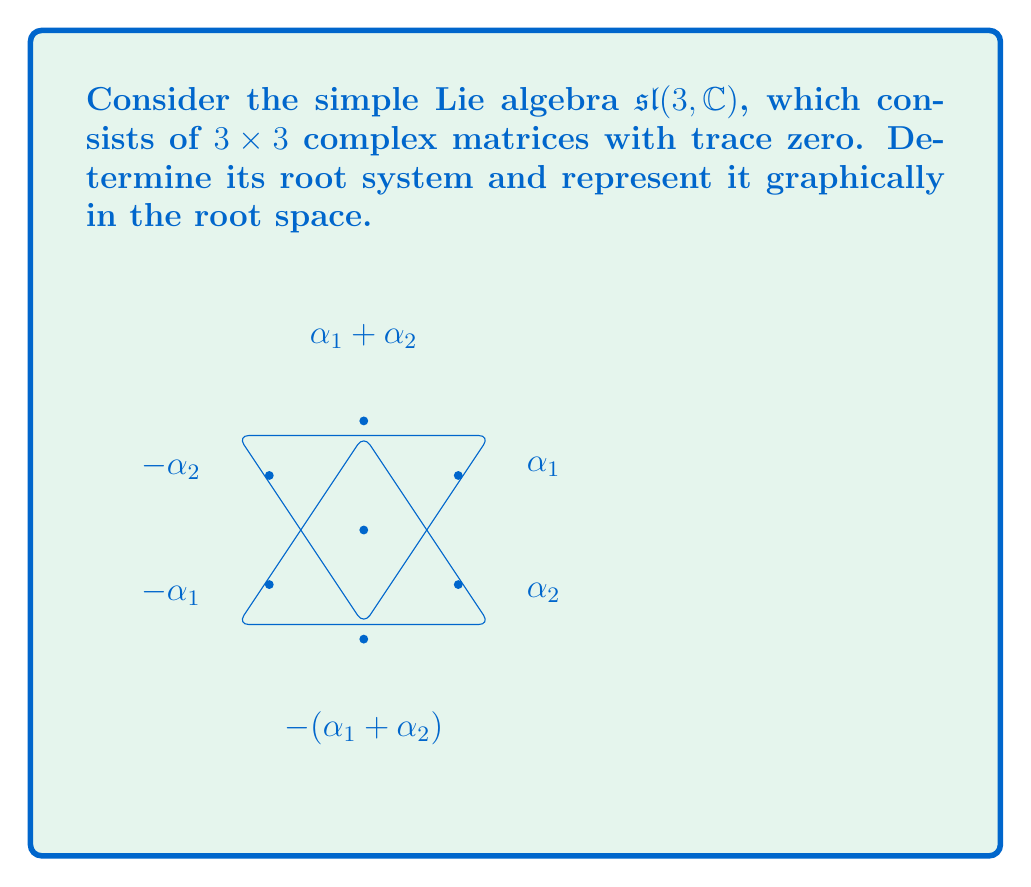Help me with this question. To find the root system of $\mathfrak{sl}(3, \mathbb{C})$, we follow these steps:

1) First, identify a Cartan subalgebra $\mathfrak{h}$. For $\mathfrak{sl}(3, \mathbb{C})$, we can choose the diagonal matrices with trace zero:

   $$\mathfrak{h} = \left\{\begin{pmatrix} a & 0 & 0 \\ 0 & b & 0 \\ 0 & 0 & -a-b \end{pmatrix} : a,b \in \mathbb{C}\right\}$$

2) Next, we find the root spaces. These are the eigenspaces of the adjoint action of $\mathfrak{h}$ on $\mathfrak{sl}(3, \mathbb{C})$. The roots are the corresponding eigenvalues.

3) We can represent the roots as linear functionals on $\mathfrak{h}$. Let $e_1, e_2, e_3$ be the standard basis of $\mathbb{C}^3$. Then the roots are:

   $$\alpha_1 = e_1 - e_2, \alpha_2 = e_2 - e_3, \alpha_1 + \alpha_2 = e_1 - e_3$$
   $$-\alpha_1 = e_2 - e_1, -\alpha_2 = e_3 - e_2, -(\alpha_1 + \alpha_2) = e_3 - e_1$$

4) These six roots form the root system of $\mathfrak{sl}(3, \mathbb{C})$. We can choose $\alpha_1$ and $\alpha_2$ as simple roots.

5) The root system can be represented graphically in a two-dimensional root space, as shown in the diagram. The roots form a hexagon, with the simple roots $\alpha_1$ and $\alpha_2$ at an angle of 120° to each other.

This root system is known as $A_2$, which is the root system for all special linear Lie algebras $\mathfrak{sl}(3, \mathbb{F})$ over any field $\mathbb{F}$.
Answer: $\{\pm(e_1-e_2), \pm(e_2-e_3), \pm(e_1-e_3)\}$ 